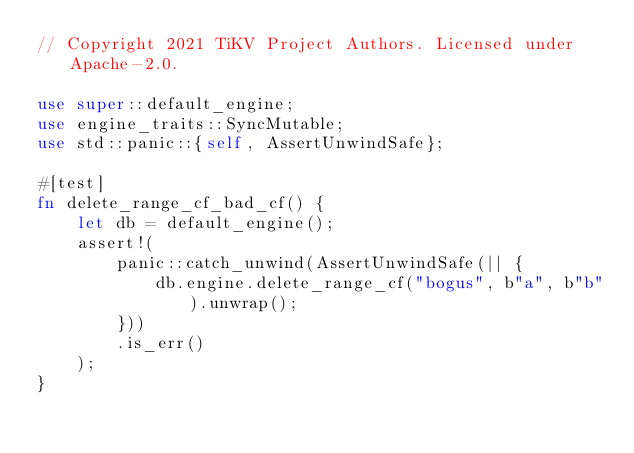<code> <loc_0><loc_0><loc_500><loc_500><_Rust_>// Copyright 2021 TiKV Project Authors. Licensed under Apache-2.0.

use super::default_engine;
use engine_traits::SyncMutable;
use std::panic::{self, AssertUnwindSafe};

#[test]
fn delete_range_cf_bad_cf() {
    let db = default_engine();
    assert!(
        panic::catch_unwind(AssertUnwindSafe(|| {
            db.engine.delete_range_cf("bogus", b"a", b"b").unwrap();
        }))
        .is_err()
    );
}
</code> 